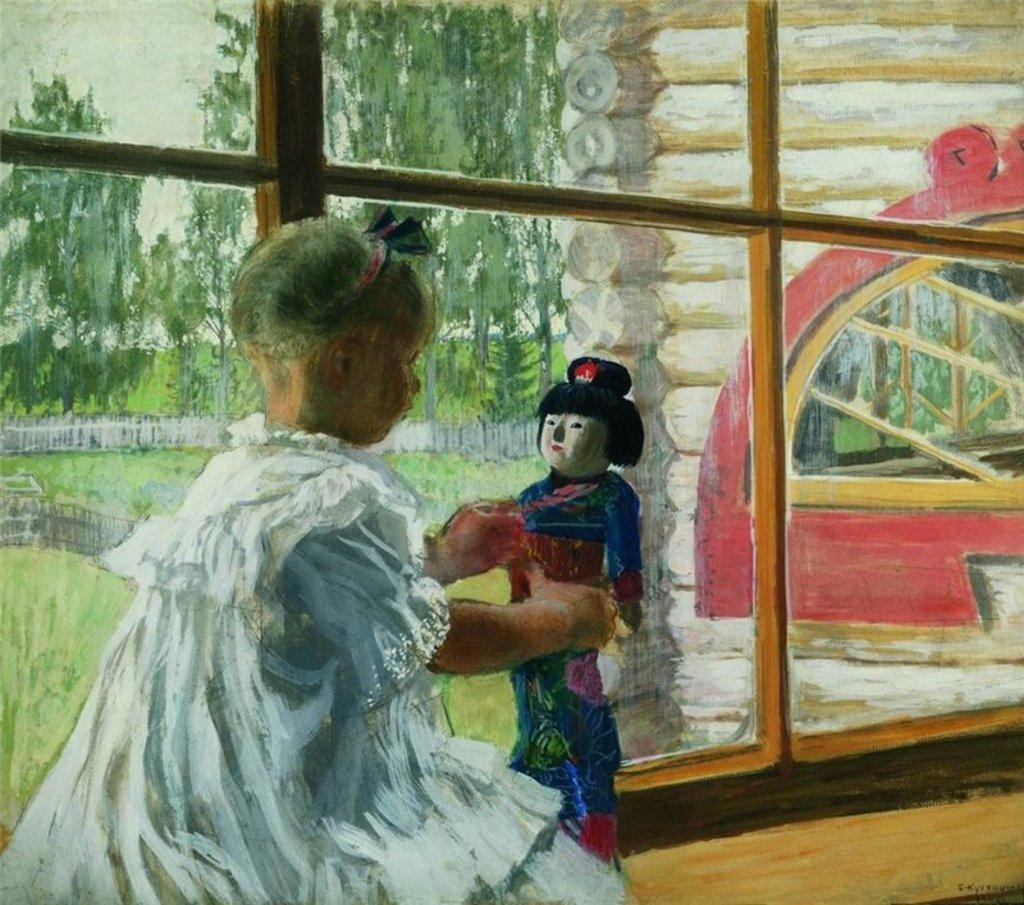What is depicted in the painting in the image? There is a painting of a person holding an object in the image. What type of structure can be seen in the image? There is a wall visible in the image. What architectural features are present in the image? There are windows in the image. What type of natural environment is visible in the image? There is grass and trees visible in the image. How many tomatoes are growing on the person's toe in the image? There are no tomatoes or toes visible in the image; the painting features a person holding an object, and the surrounding environment includes a wall, windows, grass, and trees. 